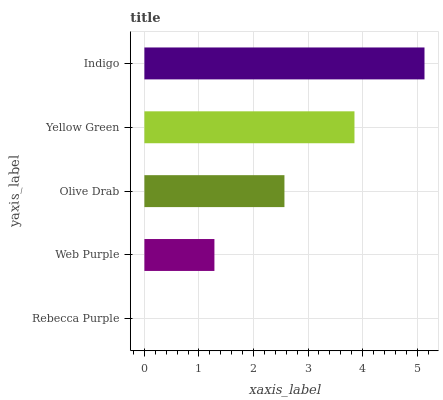Is Rebecca Purple the minimum?
Answer yes or no. Yes. Is Indigo the maximum?
Answer yes or no. Yes. Is Web Purple the minimum?
Answer yes or no. No. Is Web Purple the maximum?
Answer yes or no. No. Is Web Purple greater than Rebecca Purple?
Answer yes or no. Yes. Is Rebecca Purple less than Web Purple?
Answer yes or no. Yes. Is Rebecca Purple greater than Web Purple?
Answer yes or no. No. Is Web Purple less than Rebecca Purple?
Answer yes or no. No. Is Olive Drab the high median?
Answer yes or no. Yes. Is Olive Drab the low median?
Answer yes or no. Yes. Is Rebecca Purple the high median?
Answer yes or no. No. Is Yellow Green the low median?
Answer yes or no. No. 